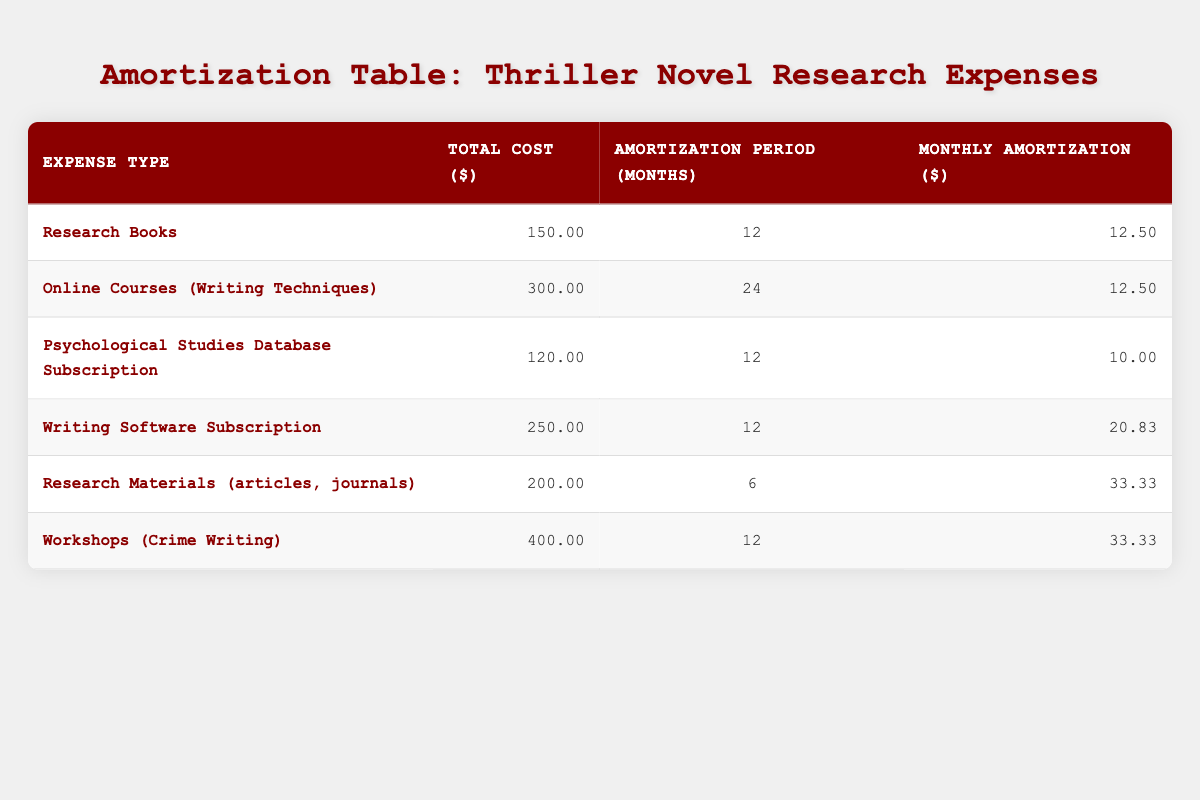What is the total cost for Research Books? The table shows that the total cost for Research Books is listed under the "Total Cost ($)" column for that specific expense type, which is 150.00.
Answer: 150.00 How long is the amortization period for the Writing Software Subscription? According to the table, the "Amortization Period (Months)" for the Writing Software Subscription is 12 months.
Answer: 12 What is the average monthly amortization for all expenses? To find the average monthly amortization, we sum the monthly amortizations: 12.50 + 12.50 + 10.00 + 20.83 + 33.33 + 33.33 = 122.49, and then divide by the number of expenses (6), yielding 122.49/6 = 20.42.
Answer: 20.42 Is the total cost of Psychological Studies Database Subscription higher than that of Research Books? The total cost of Psychological Studies Database Subscription is 120.00, and the total cost of Research Books is 150.00; therefore, 120.00 is not higher than 150.00.
Answer: No What is the total amortization period for all expenses combined? We add the amortization periods for all expenses: 12 + 24 + 12 + 12 + 6 + 12 = 78 months.
Answer: 78 months What is the highest monthly amortization among the expenses listed? By examining the "Monthly Amortization ($)" column, we see the highest value is 33.33 from both Research Materials and Workshops.
Answer: 33.33 What is the total cost for Online Courses (Writing Techniques) and Workshops (Crime Writing) combined? The total costs are 300.00 for Online Courses and 400.00 for Workshops. Adding these gives us 300.00 + 400.00 = 700.00.
Answer: 700.00 Are there any expenses with a monthly amortization of exactly 12.50? Checking the "Monthly Amortization ($)" column, it shows that both Research Books and Online Courses have a monthly amortization of 12.50, indicating that there are indeed expenses matching this amount.
Answer: Yes What percentage of the total costs is attributed to Research Materials (articles, journals)? The total costs sum is 150.00 + 300.00 + 120.00 + 250.00 + 200.00 + 400.00 = 1420.00. The cost for Research Materials is 200.00. The percentage is (200.00/1420.00) * 100 = 14.08%.
Answer: 14.08% 